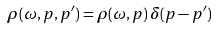<formula> <loc_0><loc_0><loc_500><loc_500>\rho ( \omega , p , p ^ { \prime } ) = \rho ( \omega , p ) \, \delta ( p - p ^ { \prime } )</formula> 